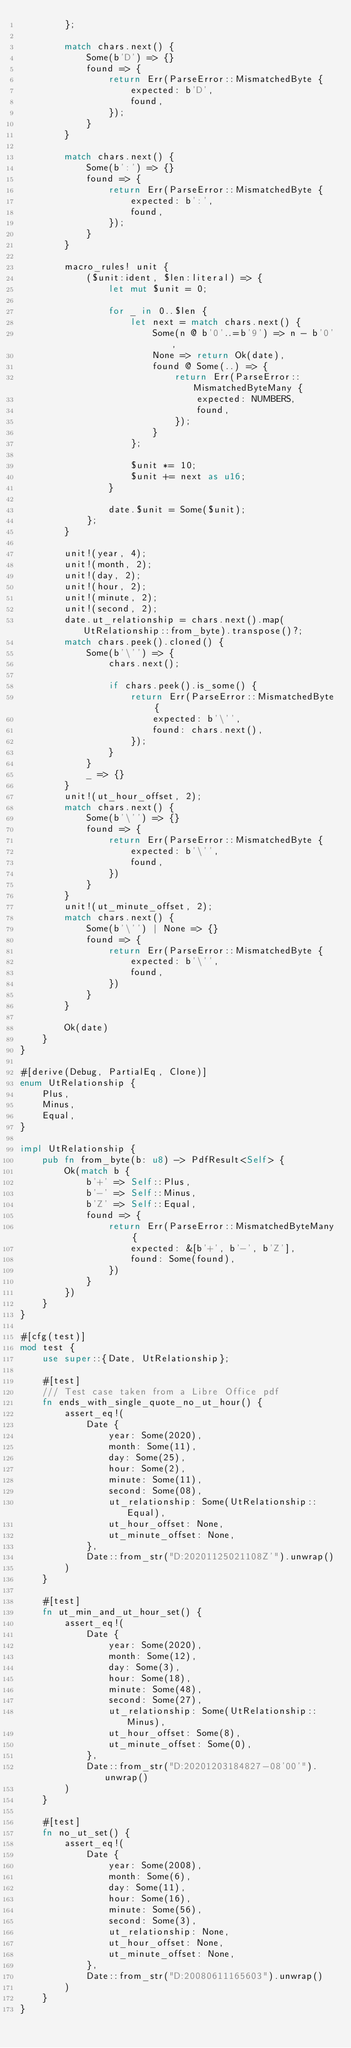<code> <loc_0><loc_0><loc_500><loc_500><_Rust_>        };

        match chars.next() {
            Some(b'D') => {}
            found => {
                return Err(ParseError::MismatchedByte {
                    expected: b'D',
                    found,
                });
            }
        }

        match chars.next() {
            Some(b':') => {}
            found => {
                return Err(ParseError::MismatchedByte {
                    expected: b':',
                    found,
                });
            }
        }

        macro_rules! unit {
            ($unit:ident, $len:literal) => {
                let mut $unit = 0;

                for _ in 0..$len {
                    let next = match chars.next() {
                        Some(n @ b'0'..=b'9') => n - b'0',
                        None => return Ok(date),
                        found @ Some(..) => {
                            return Err(ParseError::MismatchedByteMany {
                                expected: NUMBERS,
                                found,
                            });
                        }
                    };

                    $unit *= 10;
                    $unit += next as u16;
                }

                date.$unit = Some($unit);
            };
        }

        unit!(year, 4);
        unit!(month, 2);
        unit!(day, 2);
        unit!(hour, 2);
        unit!(minute, 2);
        unit!(second, 2);
        date.ut_relationship = chars.next().map(UtRelationship::from_byte).transpose()?;
        match chars.peek().cloned() {
            Some(b'\'') => {
                chars.next();

                if chars.peek().is_some() {
                    return Err(ParseError::MismatchedByte {
                        expected: b'\'',
                        found: chars.next(),
                    });
                }
            }
            _ => {}
        }
        unit!(ut_hour_offset, 2);
        match chars.next() {
            Some(b'\'') => {}
            found => {
                return Err(ParseError::MismatchedByte {
                    expected: b'\'',
                    found,
                })
            }
        }
        unit!(ut_minute_offset, 2);
        match chars.next() {
            Some(b'\'') | None => {}
            found => {
                return Err(ParseError::MismatchedByte {
                    expected: b'\'',
                    found,
                })
            }
        }

        Ok(date)
    }
}

#[derive(Debug, PartialEq, Clone)]
enum UtRelationship {
    Plus,
    Minus,
    Equal,
}

impl UtRelationship {
    pub fn from_byte(b: u8) -> PdfResult<Self> {
        Ok(match b {
            b'+' => Self::Plus,
            b'-' => Self::Minus,
            b'Z' => Self::Equal,
            found => {
                return Err(ParseError::MismatchedByteMany {
                    expected: &[b'+', b'-', b'Z'],
                    found: Some(found),
                })
            }
        })
    }
}

#[cfg(test)]
mod test {
    use super::{Date, UtRelationship};

    #[test]
    /// Test case taken from a Libre Office pdf
    fn ends_with_single_quote_no_ut_hour() {
        assert_eq!(
            Date {
                year: Some(2020),
                month: Some(11),
                day: Some(25),
                hour: Some(2),
                minute: Some(11),
                second: Some(08),
                ut_relationship: Some(UtRelationship::Equal),
                ut_hour_offset: None,
                ut_minute_offset: None,
            },
            Date::from_str("D:20201125021108Z'").unwrap()
        )
    }

    #[test]
    fn ut_min_and_ut_hour_set() {
        assert_eq!(
            Date {
                year: Some(2020),
                month: Some(12),
                day: Some(3),
                hour: Some(18),
                minute: Some(48),
                second: Some(27),
                ut_relationship: Some(UtRelationship::Minus),
                ut_hour_offset: Some(8),
                ut_minute_offset: Some(0),
            },
            Date::from_str("D:20201203184827-08'00'").unwrap()
        )
    }

    #[test]
    fn no_ut_set() {
        assert_eq!(
            Date {
                year: Some(2008),
                month: Some(6),
                day: Some(11),
                hour: Some(16),
                minute: Some(56),
                second: Some(3),
                ut_relationship: None,
                ut_hour_offset: None,
                ut_minute_offset: None,
            },
            Date::from_str("D:20080611165603").unwrap()
        )
    }
}
</code> 